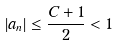Convert formula to latex. <formula><loc_0><loc_0><loc_500><loc_500>| a _ { n } | \leq \frac { C + 1 } { 2 } < 1</formula> 